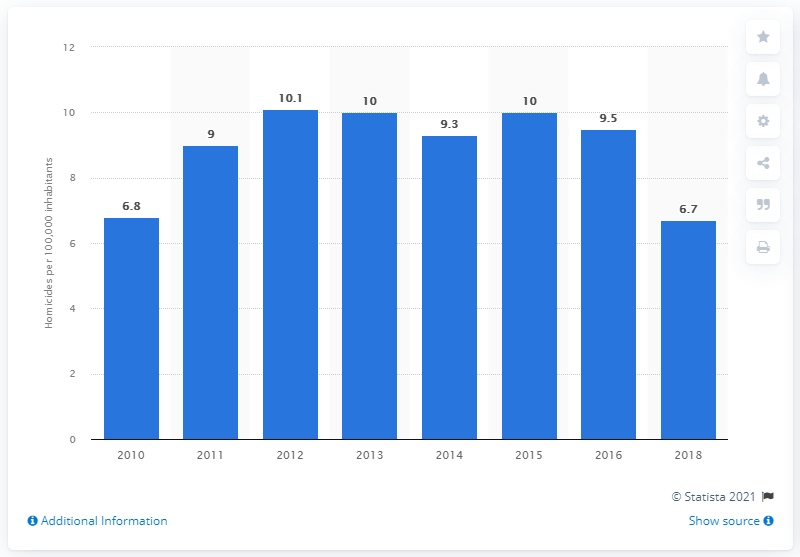Specify some key components in this picture. Haiti's homicide rate two years earlier was 9.5. According to data from 2018, the homicide rate in Haiti was 6.7. 